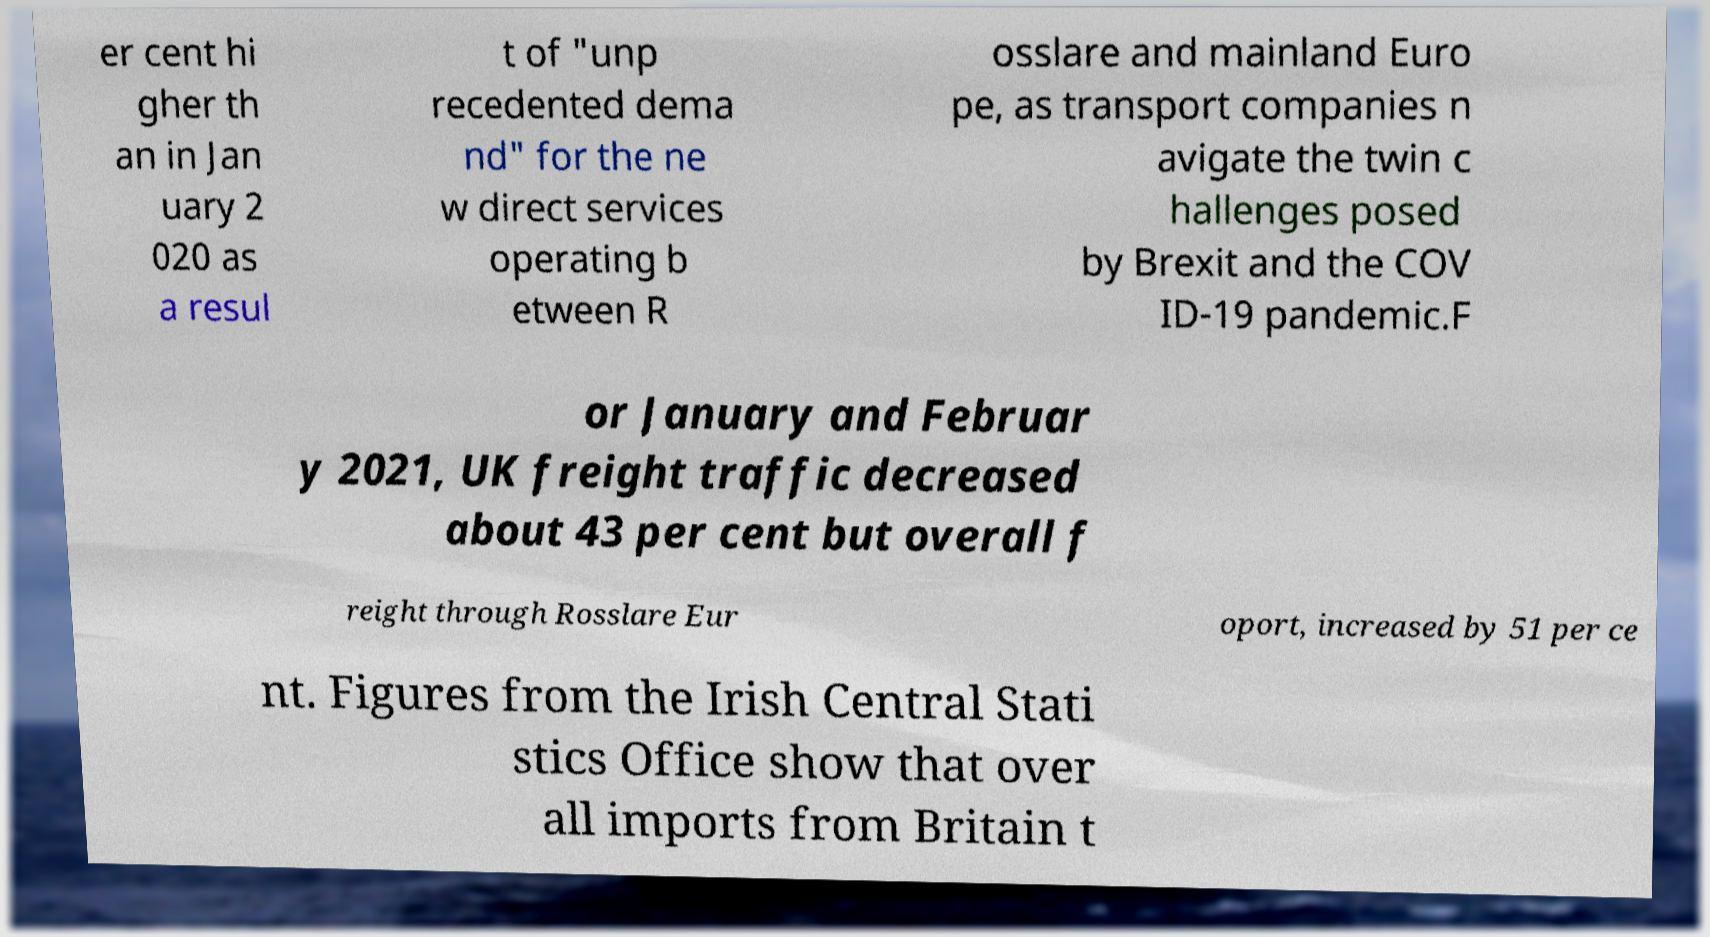Could you assist in decoding the text presented in this image and type it out clearly? er cent hi gher th an in Jan uary 2 020 as a resul t of "unp recedented dema nd" for the ne w direct services operating b etween R osslare and mainland Euro pe, as transport companies n avigate the twin c hallenges posed by Brexit and the COV ID-19 pandemic.F or January and Februar y 2021, UK freight traffic decreased about 43 per cent but overall f reight through Rosslare Eur oport, increased by 51 per ce nt. Figures from the Irish Central Stati stics Office show that over all imports from Britain t 